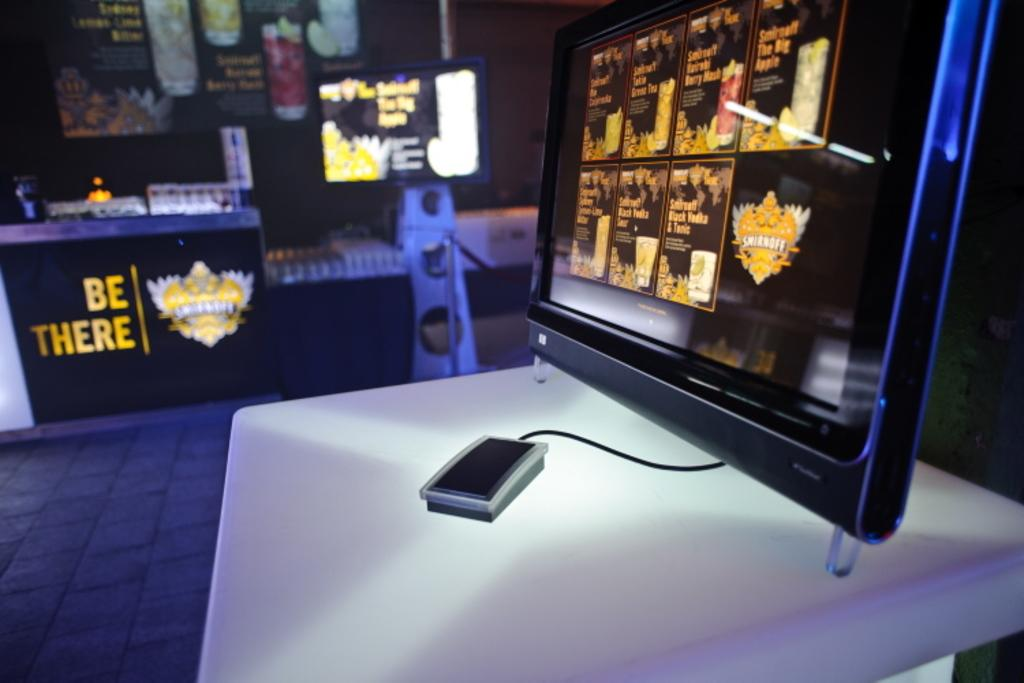<image>
Share a concise interpretation of the image provided. A Smirnoff logo is visible on a monitor next to several different pictures of drinks. 